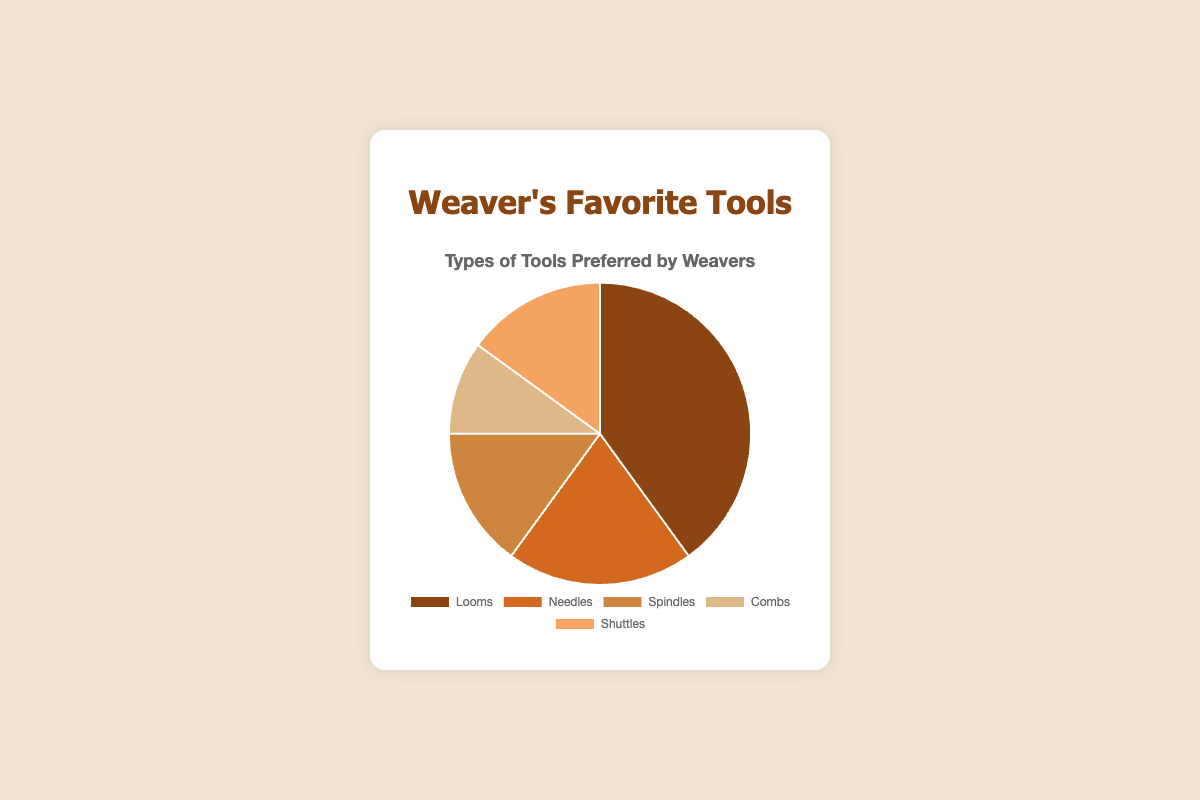What percentage of weavers prefer looms over all other tools? Looms have a percentage of 40. This is the highest percentage among all the tools, indicating that 40% of weavers prefer looms over all other tools.
Answer: 40% Which tool is the least preferred by the weavers? By comparing the percentages in the pie chart, Combs have the lowest percentage at 10, making it the least preferred tool by weavers.
Answer: Combs What's the total percentage of weavers that prefer Spindles and Shuttles combined? The percentage of weavers who prefer Spindles is 15, and for Shuttles, it is also 15. Adding these two gives us 15 + 15 = 30.
Answer: 30% Are Looms preferred by more weavers than Needles and Combs combined? The percentage for Looms is 40, while Needles and Combs have 20 and 10 respectively. Adding Needles and Combs gives 20 + 10 = 30, which is less than 40.
Answer: Yes Which tool has the closest preference percentage to Spindles? The percentage for Spindles is 15, and the closest percentage to this is Shuttles, which also has 15%, indicating they have an equal preference.
Answer: Shuttles What is the average percentage preference for Needles, Spindles, and Shuttles? The percentages are Needles (20), Spindles (15), and Shuttles (15). Adding these gives 20 + 15 + 15 = 50, and the average is 50/3 ≈ 16.67.
Answer: 16.67% By what percentage do Looms exceed Combs in preference? Looms are at 40% while Combs are at 10%. Therefore, the difference is 40 - 10 = 30%.
Answer: 30% How do the percentages of Needles and Spindles compare visually? Both Needles (20%) and Spindles (15%) segments can be seen in the pie chart, with Needles taking a visibly larger portion of the pie compared to Spindles.
Answer: Needles > Spindles If you combine the preference for all tools other than Looms, what would the total percentage be? The percentages for all tools other than Looms are: Needles (20), Spindles (15), Combs (10), and Shuttles (15). Adding these gives 20 + 15 + 10 + 15 = 60.
Answer: 60% 